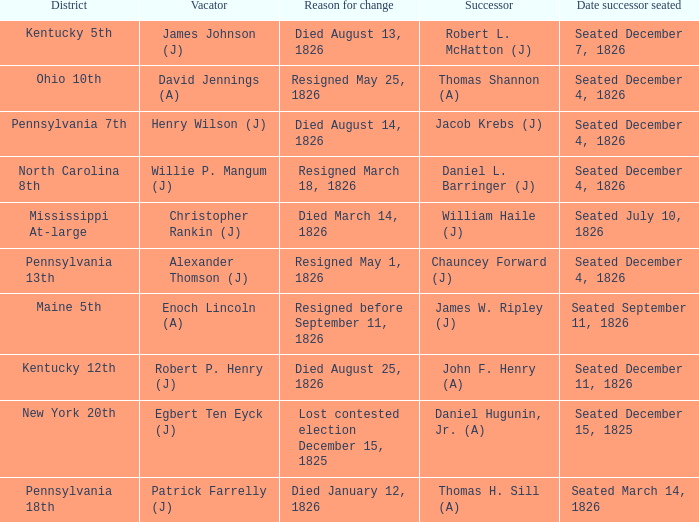Name the vacator for reason for change died january 12, 1826 Patrick Farrelly (J). 